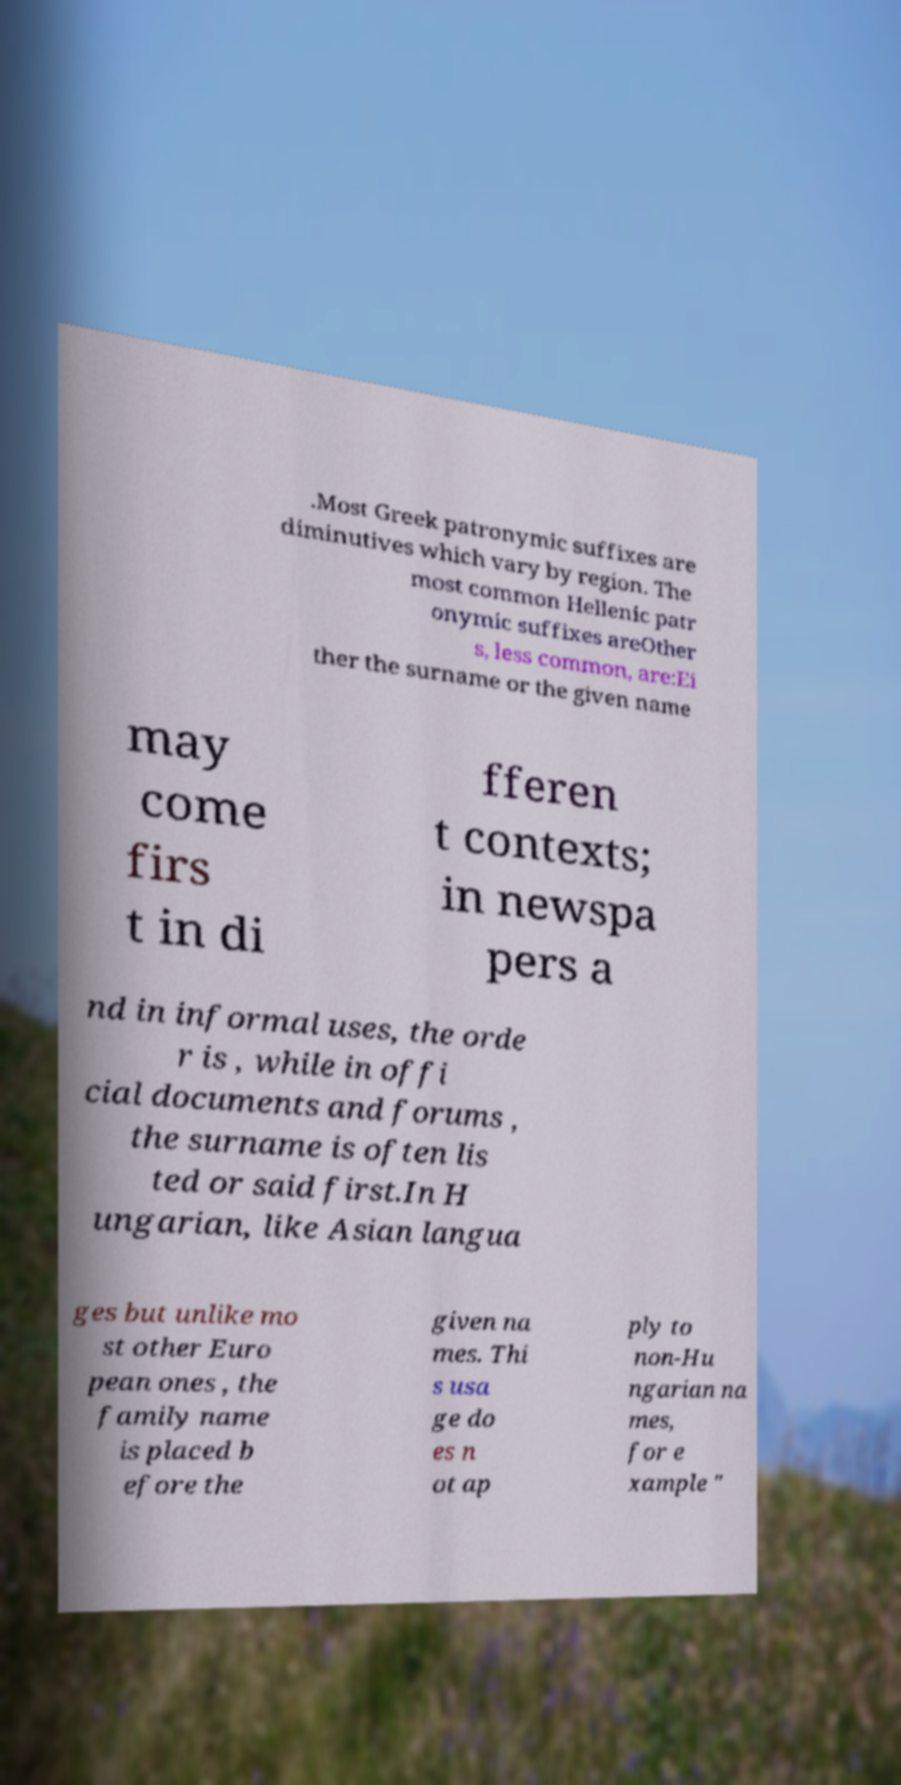Please identify and transcribe the text found in this image. .Most Greek patronymic suffixes are diminutives which vary by region. The most common Hellenic patr onymic suffixes areOther s, less common, are:Ei ther the surname or the given name may come firs t in di fferen t contexts; in newspa pers a nd in informal uses, the orde r is , while in offi cial documents and forums , the surname is often lis ted or said first.In H ungarian, like Asian langua ges but unlike mo st other Euro pean ones , the family name is placed b efore the given na mes. Thi s usa ge do es n ot ap ply to non-Hu ngarian na mes, for e xample " 